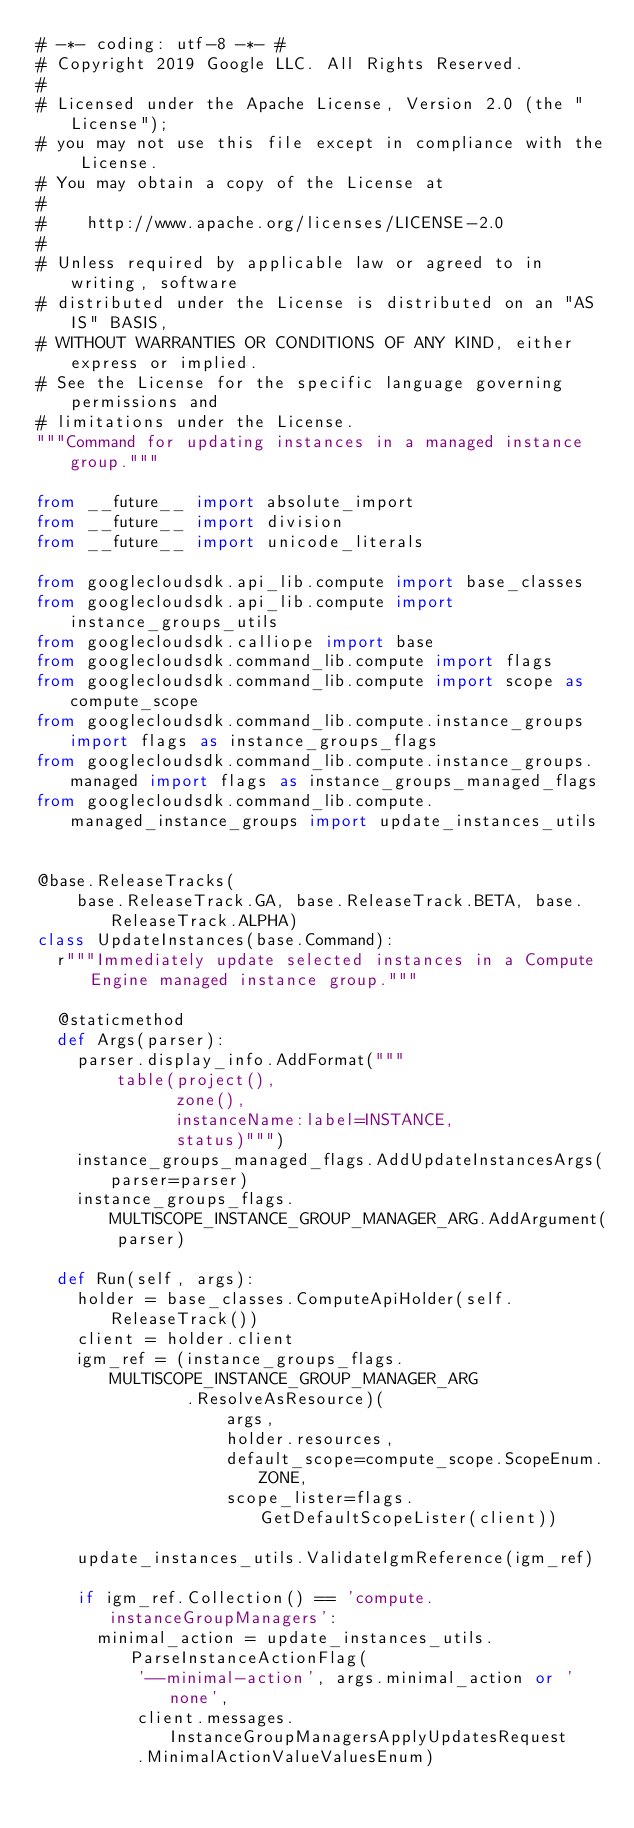Convert code to text. <code><loc_0><loc_0><loc_500><loc_500><_Python_># -*- coding: utf-8 -*- #
# Copyright 2019 Google LLC. All Rights Reserved.
#
# Licensed under the Apache License, Version 2.0 (the "License");
# you may not use this file except in compliance with the License.
# You may obtain a copy of the License at
#
#    http://www.apache.org/licenses/LICENSE-2.0
#
# Unless required by applicable law or agreed to in writing, software
# distributed under the License is distributed on an "AS IS" BASIS,
# WITHOUT WARRANTIES OR CONDITIONS OF ANY KIND, either express or implied.
# See the License for the specific language governing permissions and
# limitations under the License.
"""Command for updating instances in a managed instance group."""

from __future__ import absolute_import
from __future__ import division
from __future__ import unicode_literals

from googlecloudsdk.api_lib.compute import base_classes
from googlecloudsdk.api_lib.compute import instance_groups_utils
from googlecloudsdk.calliope import base
from googlecloudsdk.command_lib.compute import flags
from googlecloudsdk.command_lib.compute import scope as compute_scope
from googlecloudsdk.command_lib.compute.instance_groups import flags as instance_groups_flags
from googlecloudsdk.command_lib.compute.instance_groups.managed import flags as instance_groups_managed_flags
from googlecloudsdk.command_lib.compute.managed_instance_groups import update_instances_utils


@base.ReleaseTracks(
    base.ReleaseTrack.GA, base.ReleaseTrack.BETA, base.ReleaseTrack.ALPHA)
class UpdateInstances(base.Command):
  r"""Immediately update selected instances in a Compute Engine managed instance group."""

  @staticmethod
  def Args(parser):
    parser.display_info.AddFormat("""
        table(project(),
              zone(),
              instanceName:label=INSTANCE,
              status)""")
    instance_groups_managed_flags.AddUpdateInstancesArgs(parser=parser)
    instance_groups_flags.MULTISCOPE_INSTANCE_GROUP_MANAGER_ARG.AddArgument(
        parser)

  def Run(self, args):
    holder = base_classes.ComputeApiHolder(self.ReleaseTrack())
    client = holder.client
    igm_ref = (instance_groups_flags.MULTISCOPE_INSTANCE_GROUP_MANAGER_ARG
               .ResolveAsResource)(
                   args,
                   holder.resources,
                   default_scope=compute_scope.ScopeEnum.ZONE,
                   scope_lister=flags.GetDefaultScopeLister(client))

    update_instances_utils.ValidateIgmReference(igm_ref)

    if igm_ref.Collection() == 'compute.instanceGroupManagers':
      minimal_action = update_instances_utils.ParseInstanceActionFlag(
          '--minimal-action', args.minimal_action or 'none',
          client.messages.InstanceGroupManagersApplyUpdatesRequest
          .MinimalActionValueValuesEnum)</code> 